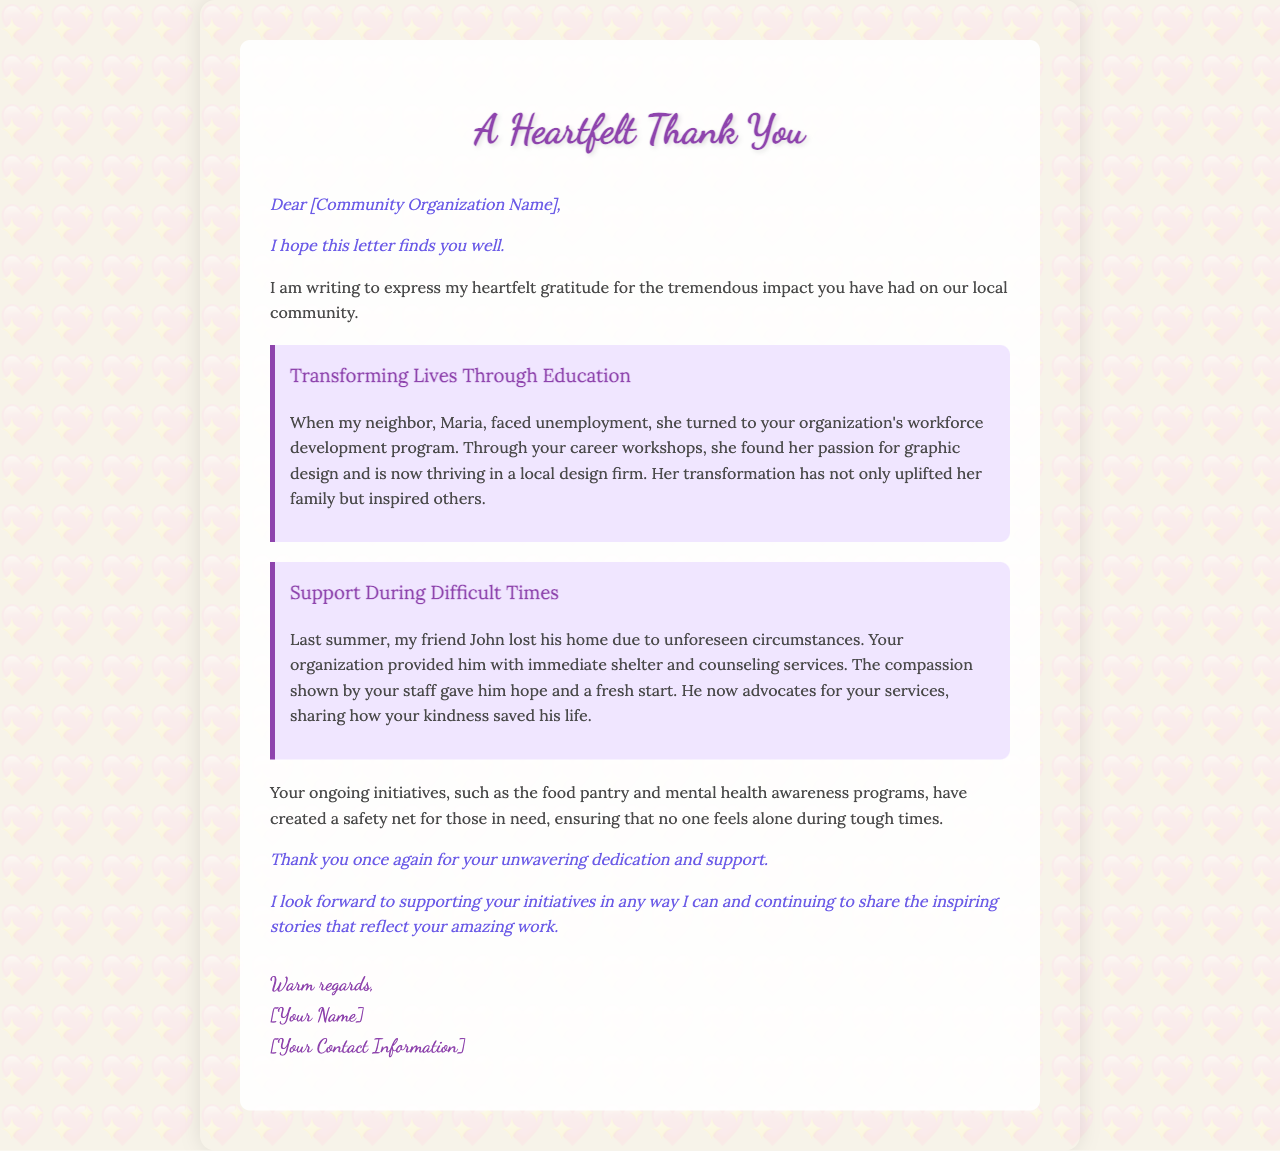What is the title of the letter? The title of the letter is indicated at the top of the document.
Answer: A Heartfelt Thank You Who is the letter addressed to? The letter begins with a direct address to the community organization.
Answer: [Community Organization Name] Which program did Maria participate in? Maria engaged with the specific program offered by the organization aimed at workforce development.
Answer: workforce development program What did John lose last summer? The letter mentions an unexpected event that impacted John's living situation during the previous summer.
Answer: his home What are some of the ongoing initiatives mentioned? Several initiatives that the organization runs are indicated in the letter, contributing to community support.
Answer: food pantry and mental health awareness programs What effect did Maria's success have on others? The letter discusses the impact of Maria's transformation on the broader community.
Answer: inspired others How does John feel about the organization now? The letter reflects John's changed perspective after receiving assistance from the organization.
Answer: advocates for your services What is the overall tone of the letter? The style and language of the letter convey the writer's sentiments and purpose effectively.
Answer: compassionate 